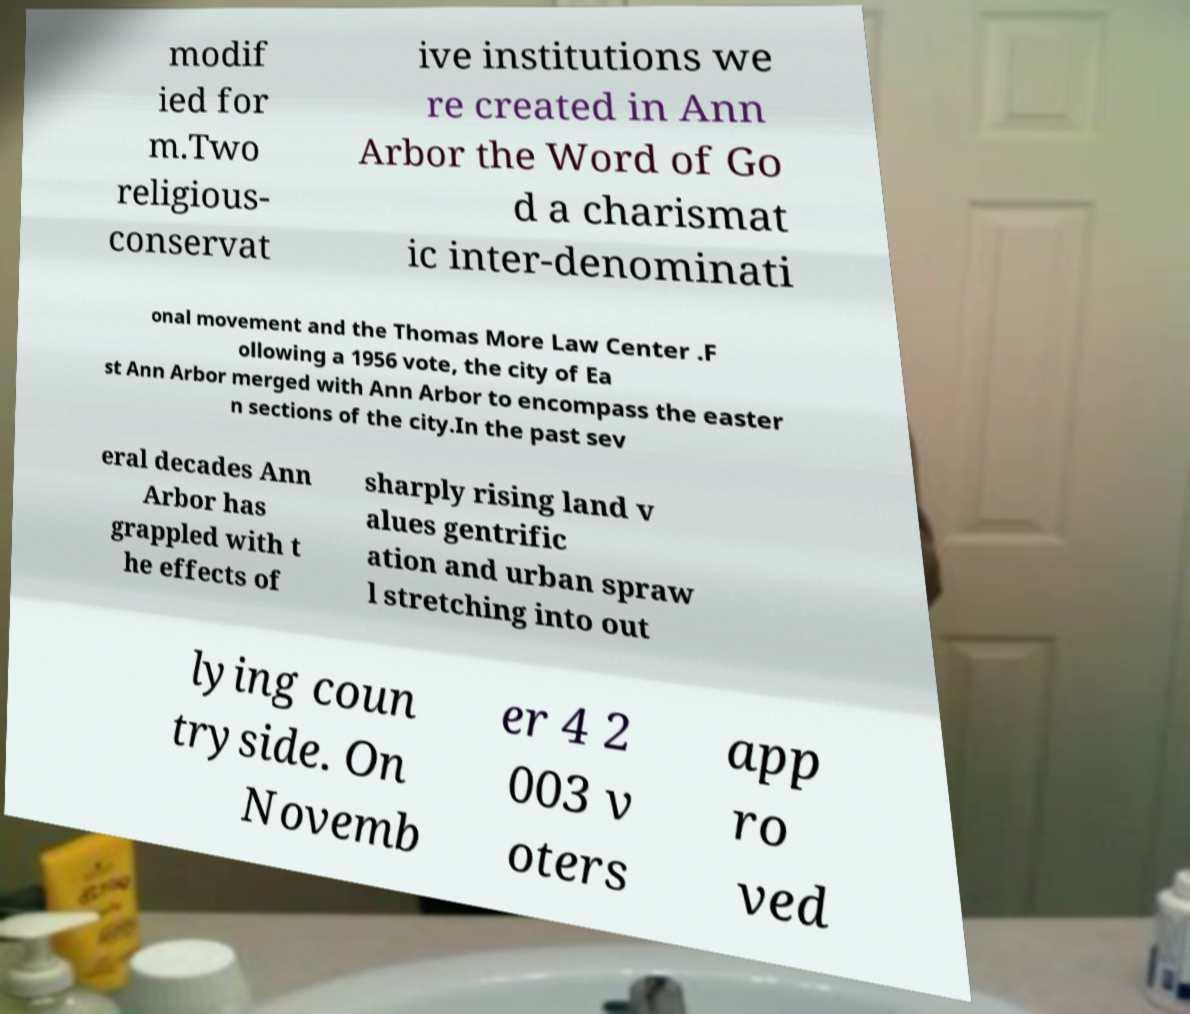Could you assist in decoding the text presented in this image and type it out clearly? modif ied for m.Two religious- conservat ive institutions we re created in Ann Arbor the Word of Go d a charismat ic inter-denominati onal movement and the Thomas More Law Center .F ollowing a 1956 vote, the city of Ea st Ann Arbor merged with Ann Arbor to encompass the easter n sections of the city.In the past sev eral decades Ann Arbor has grappled with t he effects of sharply rising land v alues gentrific ation and urban spraw l stretching into out lying coun tryside. On Novemb er 4 2 003 v oters app ro ved 